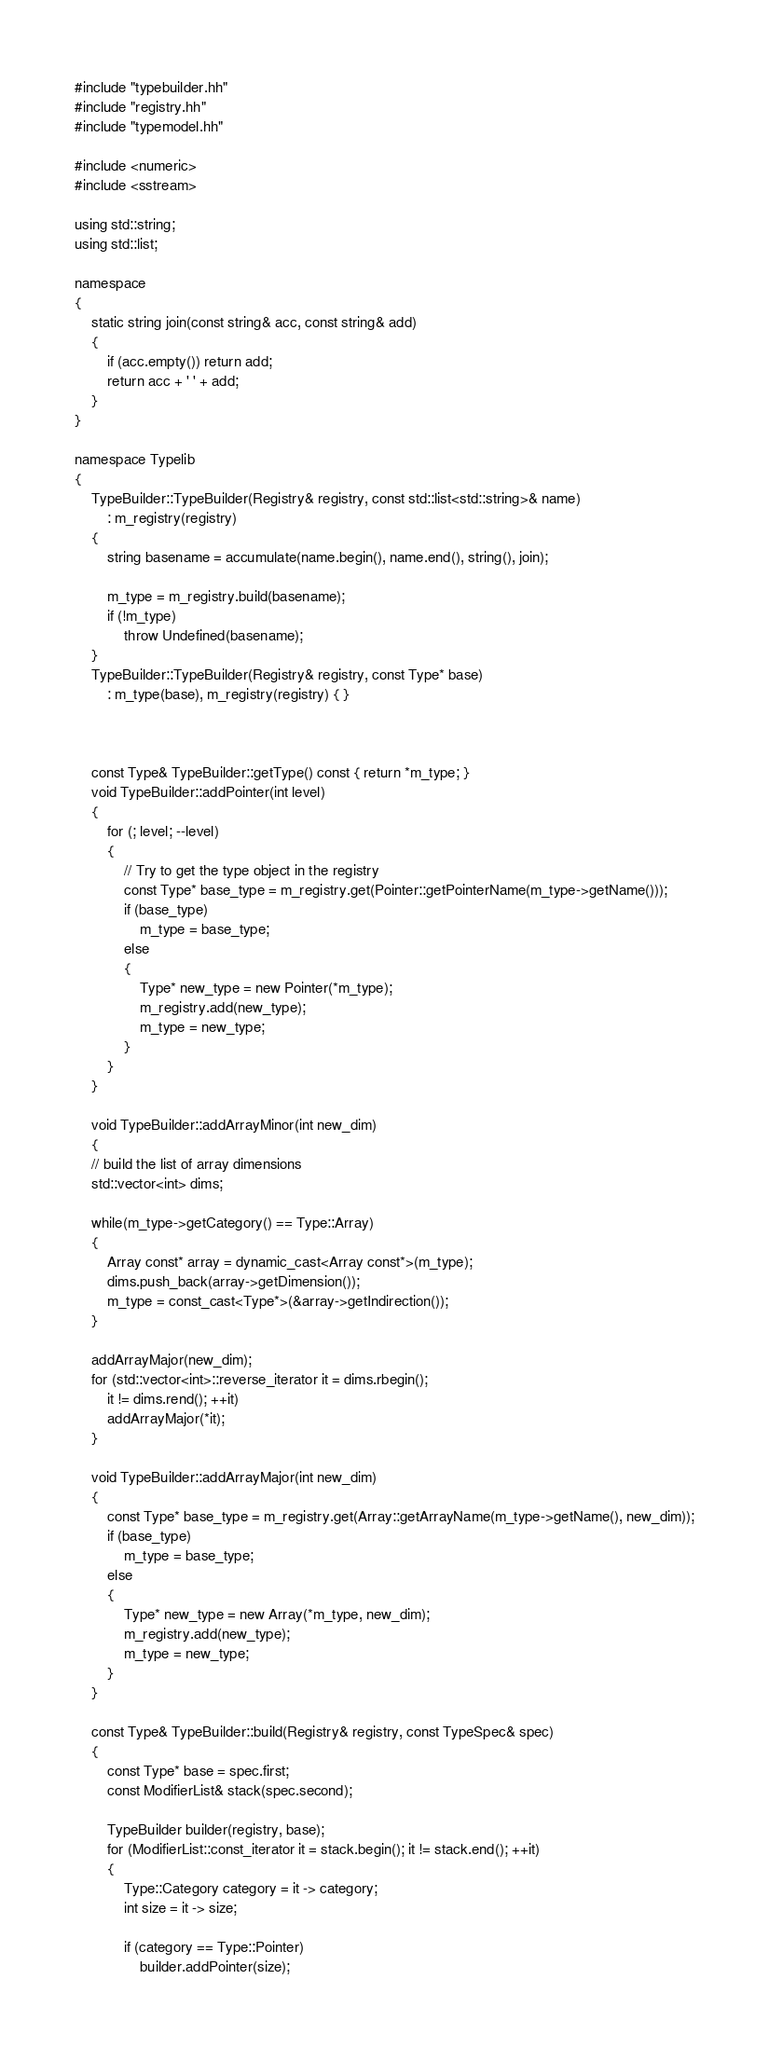<code> <loc_0><loc_0><loc_500><loc_500><_C++_>#include "typebuilder.hh"
#include "registry.hh"
#include "typemodel.hh"

#include <numeric>
#include <sstream>

using std::string;
using std::list;

namespace
{
    static string join(const string& acc, const string& add)
    {
        if (acc.empty()) return add;
        return acc + ' ' + add;
    }
}

namespace Typelib
{
    TypeBuilder::TypeBuilder(Registry& registry, const std::list<std::string>& name)
        : m_registry(registry) 
    {
        string basename = accumulate(name.begin(), name.end(), string(), join);
        
        m_type = m_registry.build(basename);
        if (!m_type) 
            throw Undefined(basename);
    }
    TypeBuilder::TypeBuilder(Registry& registry, const Type* base)
        : m_type(base), m_registry(registry) { }



    const Type& TypeBuilder::getType() const { return *m_type; }
    void TypeBuilder::addPointer(int level) 
    {
        for (; level; --level)
        {
            // Try to get the type object in the registry
            const Type* base_type = m_registry.get(Pointer::getPointerName(m_type->getName()));
            if (base_type)
                m_type = base_type;
            else
            {
                Type* new_type = new Pointer(*m_type);
                m_registry.add(new_type);
                m_type = new_type;
            }
        }
    }

    void TypeBuilder::addArrayMinor(int new_dim)
    {
	// build the list of array dimensions
	std::vector<int> dims;

	while(m_type->getCategory() == Type::Array)
	{
	    Array const* array = dynamic_cast<Array const*>(m_type);
	    dims.push_back(array->getDimension());
	    m_type = const_cast<Type*>(&array->getIndirection());
	}

	addArrayMajor(new_dim);
	for (std::vector<int>::reverse_iterator it = dims.rbegin();
		it != dims.rend(); ++it)
	    addArrayMajor(*it);
    }

    void TypeBuilder::addArrayMajor(int new_dim)
    {
        const Type* base_type = m_registry.get(Array::getArrayName(m_type->getName(), new_dim));
        if (base_type)
            m_type = base_type;
        else
        {
            Type* new_type = new Array(*m_type, new_dim);
            m_registry.add(new_type);
            m_type = new_type;
        }
    }

    const Type& TypeBuilder::build(Registry& registry, const TypeSpec& spec)
    {
        const Type* base = spec.first;
        const ModifierList& stack(spec.second);

        TypeBuilder builder(registry, base);
        for (ModifierList::const_iterator it = stack.begin(); it != stack.end(); ++it)
        {
            Type::Category category = it -> category;
            int size = it -> size;

            if (category == Type::Pointer)
                builder.addPointer(size);</code> 